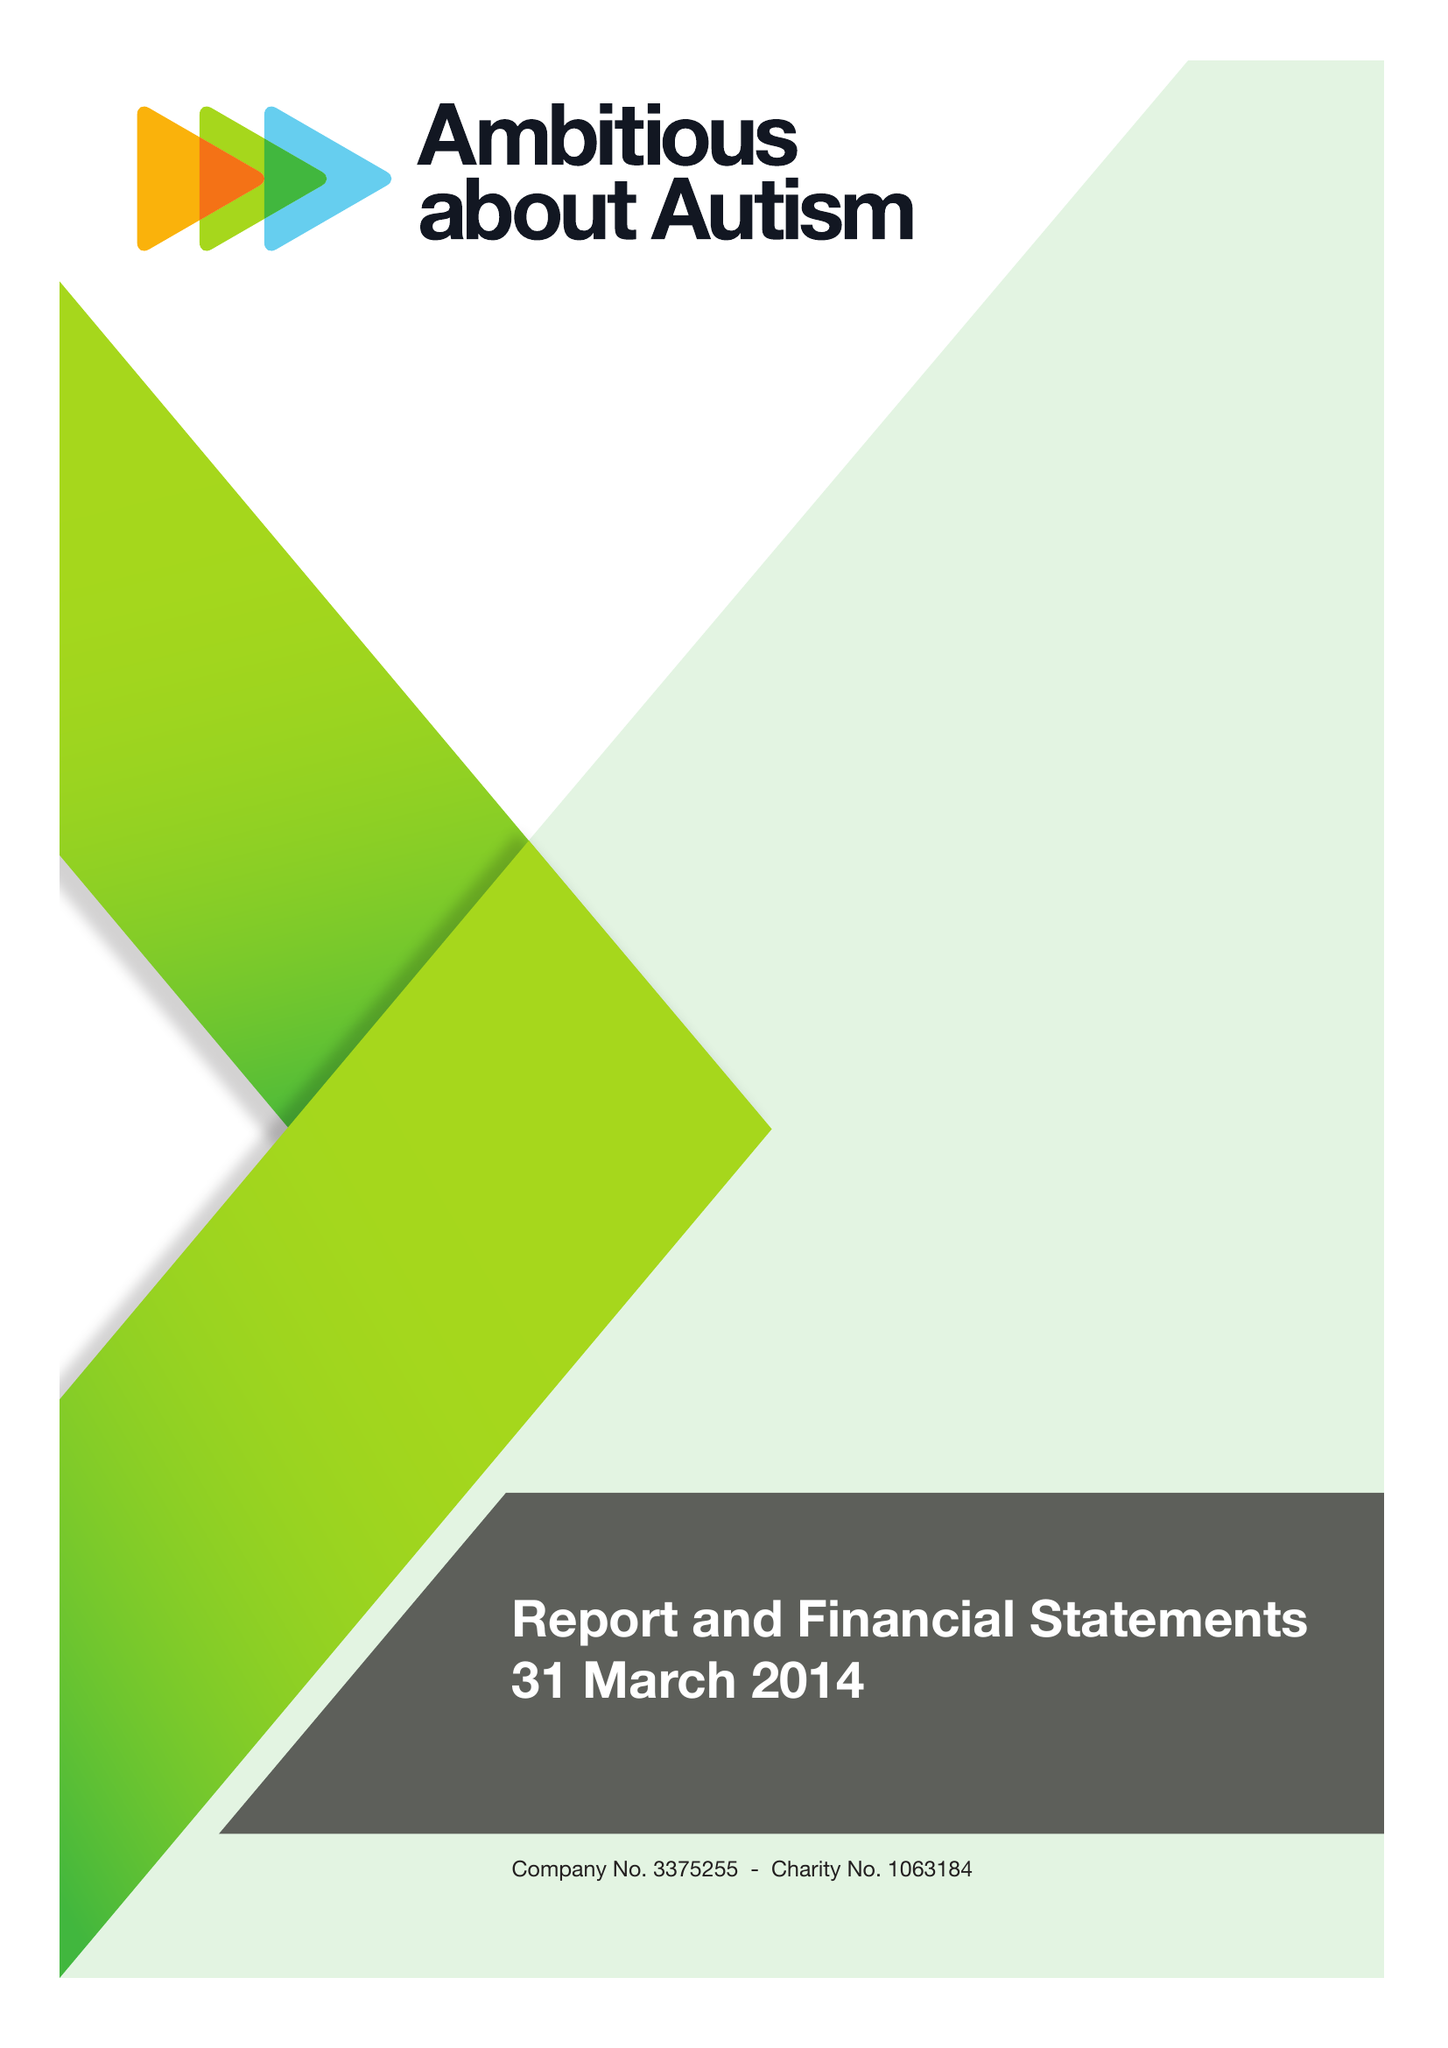What is the value for the charity_number?
Answer the question using a single word or phrase. 1063184 